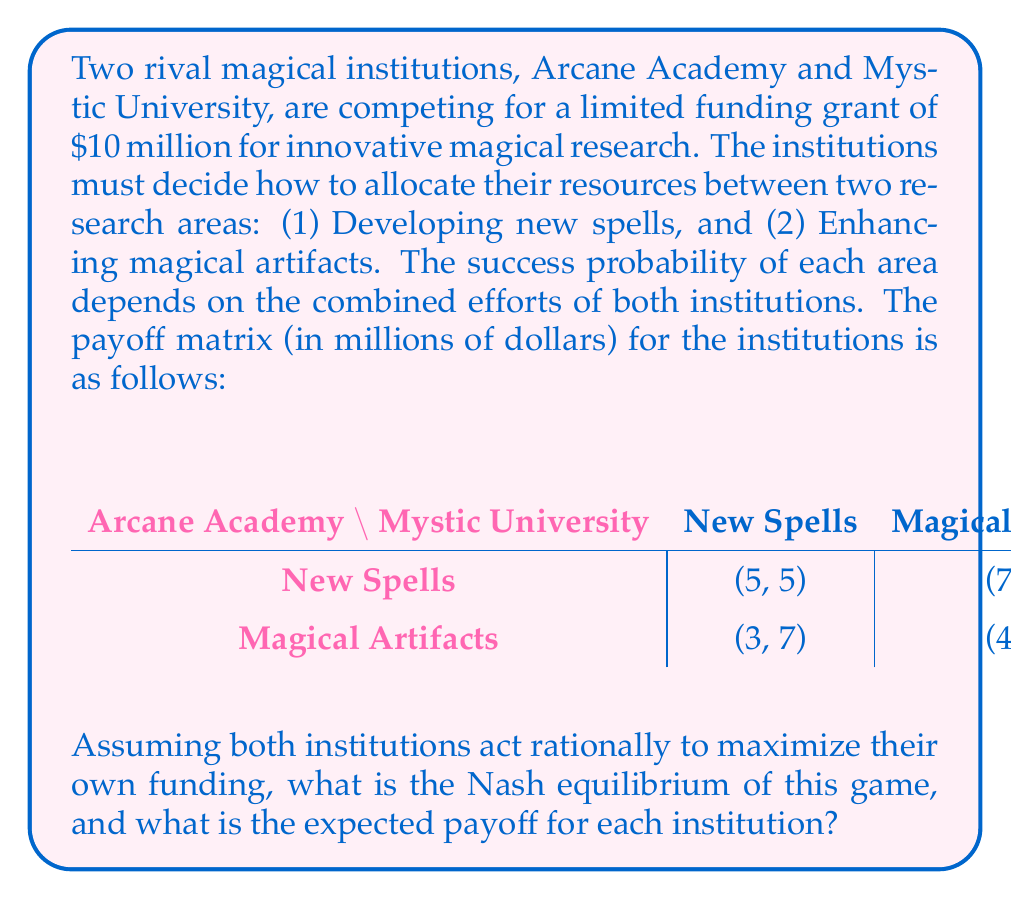Can you solve this math problem? To solve this game theory problem, we need to find the Nash equilibrium, which is a state where neither player can unilaterally change their strategy to increase their payoff. Let's analyze the game step-by-step:

1. Identify dominant strategies:
   For Arcane Academy:
   - If Mystic University chooses New Spells: 5 > 3, so Arcane Academy prefers New Spells
   - If Mystic University chooses Magical Artifacts: 7 > 4, so Arcane Academy prefers New Spells
   New Spells is a dominant strategy for Arcane Academy.

   For Mystic University:
   - If Arcane Academy chooses New Spells: 5 > 3, so Mystic University prefers New Spells
   - If Arcane Academy chooses Magical Artifacts: 7 > 4, so Mystic University prefers New Spells
   New Spells is a dominant strategy for Mystic University.

2. Identify the Nash equilibrium:
   Since both institutions have New Spells as their dominant strategy, the Nash equilibrium is (New Spells, New Spells).

3. Determine the payoff:
   At the Nash equilibrium (New Spells, New Spells), the payoff for each institution is $5 million.

This outcome represents a situation where both magical institutions focus their efforts on developing new spells, resulting in an equal split of the available funding. While they could potentially achieve a higher total payoff by cooperating and choosing different strategies, the competitive nature of the game leads them to this equilibrium.
Answer: The Nash equilibrium is (New Spells, New Spells), with an expected payoff of $5 million for each institution. 